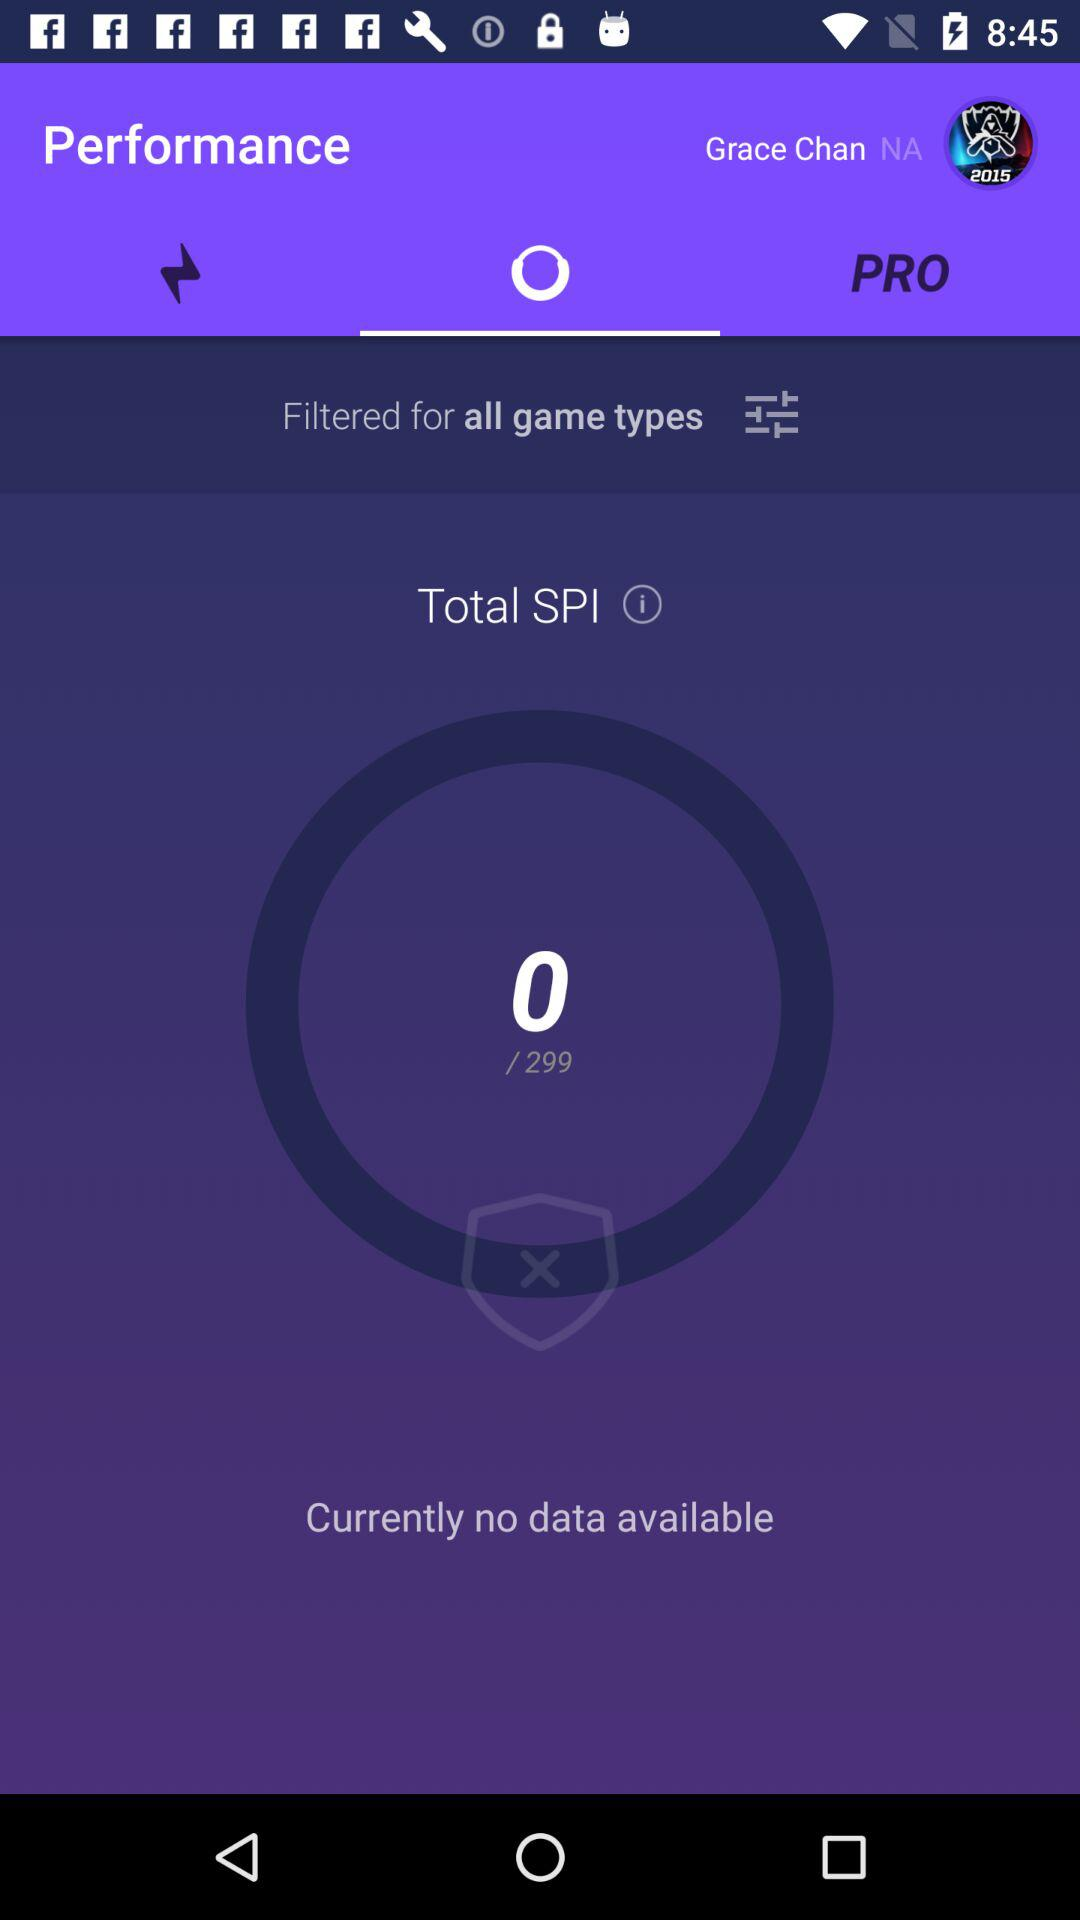How many SPI in total are there? There are 299 SPI. 